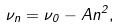<formula> <loc_0><loc_0><loc_500><loc_500>\nu _ { n } = \nu _ { 0 } - A n ^ { 2 } ,</formula> 